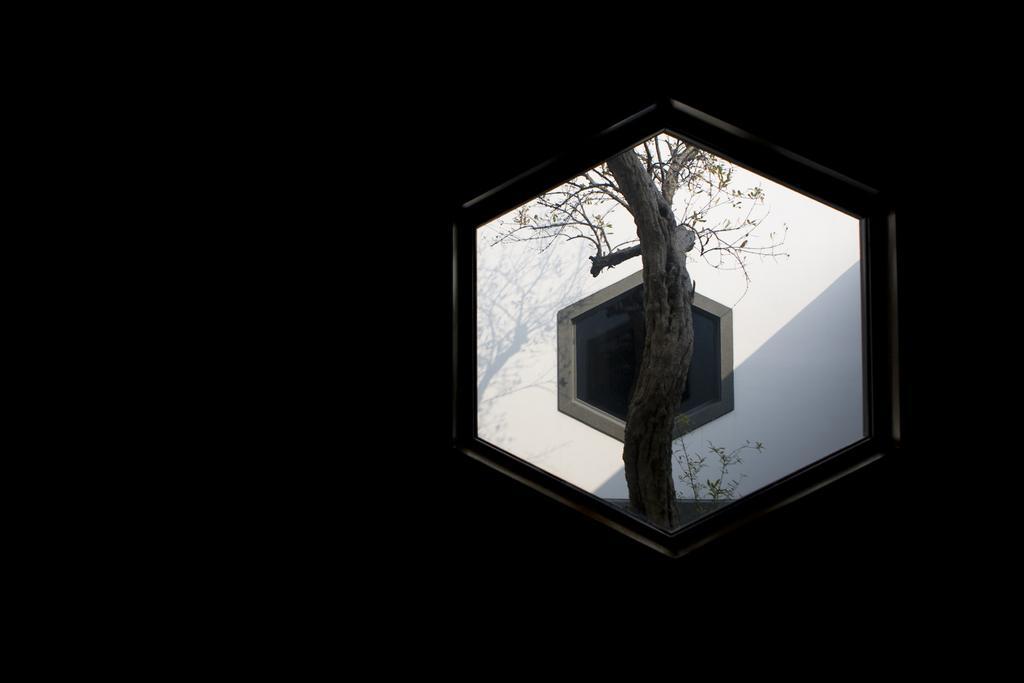In one or two sentences, can you explain what this image depicts? In this picture, it seems like a window, where we can see another window and a tree. 